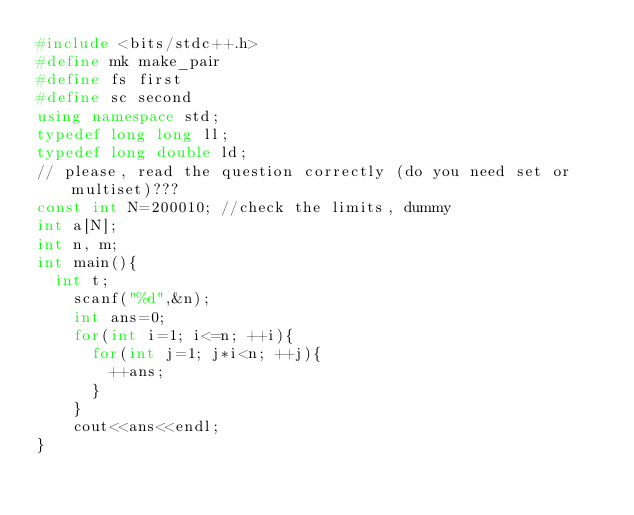Convert code to text. <code><loc_0><loc_0><loc_500><loc_500><_C++_>#include <bits/stdc++.h>
#define mk make_pair
#define fs first
#define sc second
using namespace std;
typedef long long ll;
typedef long double ld;
// please, read the question correctly (do you need set or multiset)???
const int N=200010; //check the limits, dummy
int a[N];
int n, m;
int main(){
	int t;
		scanf("%d",&n);
		int ans=0;
		for(int i=1; i<=n; ++i){
			for(int j=1; j*i<n; ++j){
				++ans;
			}
		}
		cout<<ans<<endl;
}</code> 